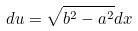Convert formula to latex. <formula><loc_0><loc_0><loc_500><loc_500>d u = \sqrt { b ^ { 2 } - a ^ { 2 } } d x</formula> 